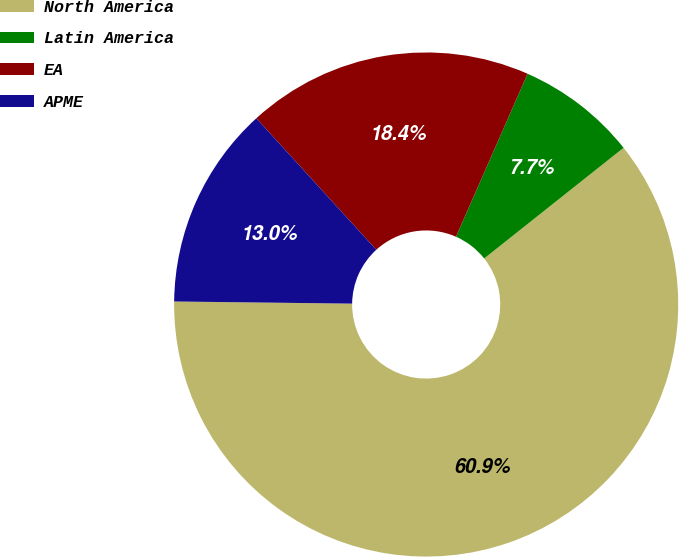<chart> <loc_0><loc_0><loc_500><loc_500><pie_chart><fcel>North America<fcel>Latin America<fcel>EA<fcel>APME<nl><fcel>60.87%<fcel>7.73%<fcel>18.36%<fcel>13.04%<nl></chart> 